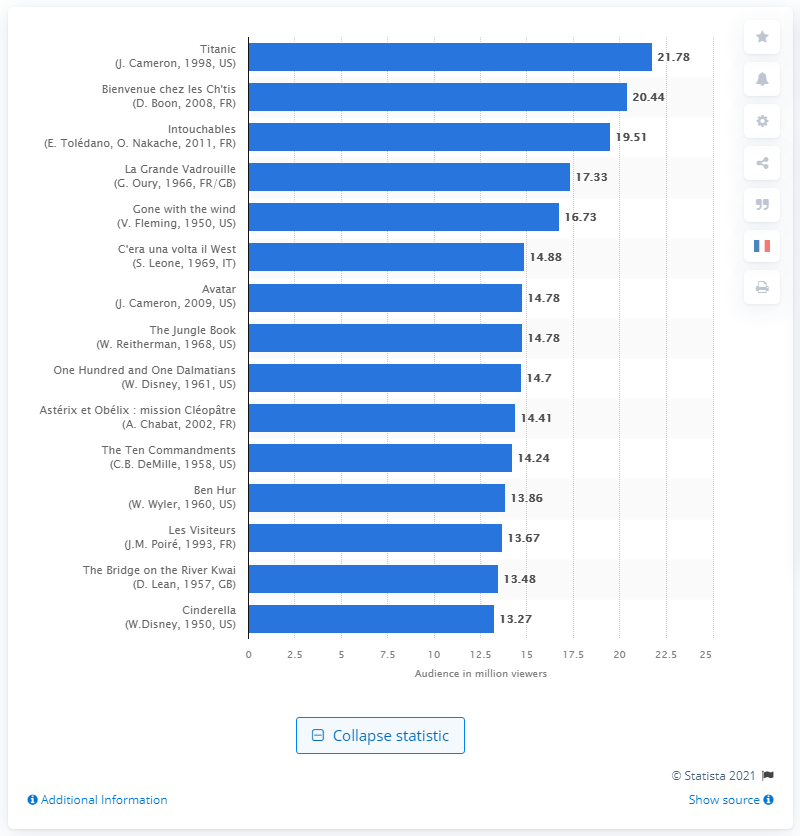Outline some significant characteristics in this image. In 1998, an estimated 21,787,268 people in France watched Titanic. 